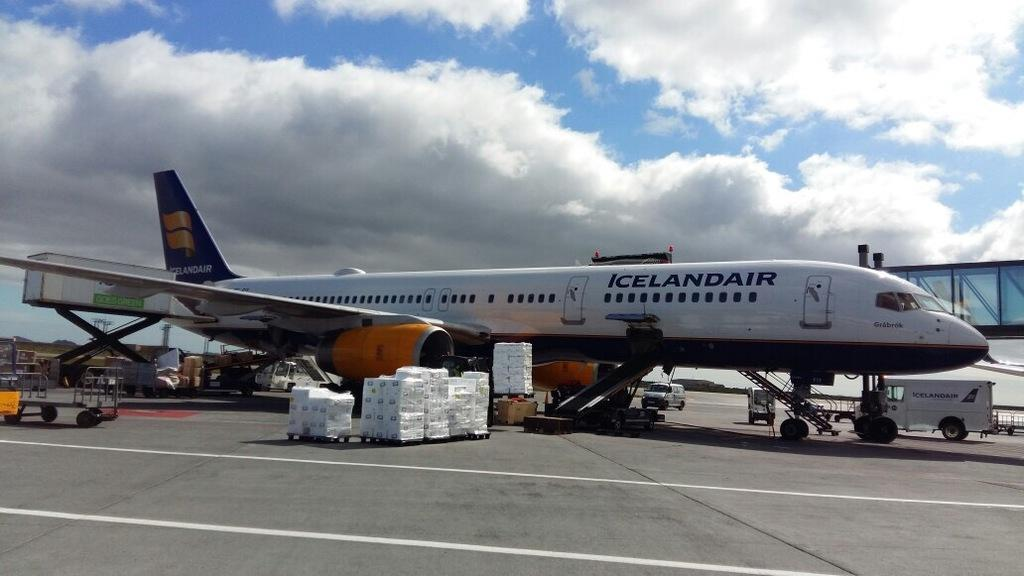<image>
Summarize the visual content of the image. An airplane from icelanair at the terminal airport 